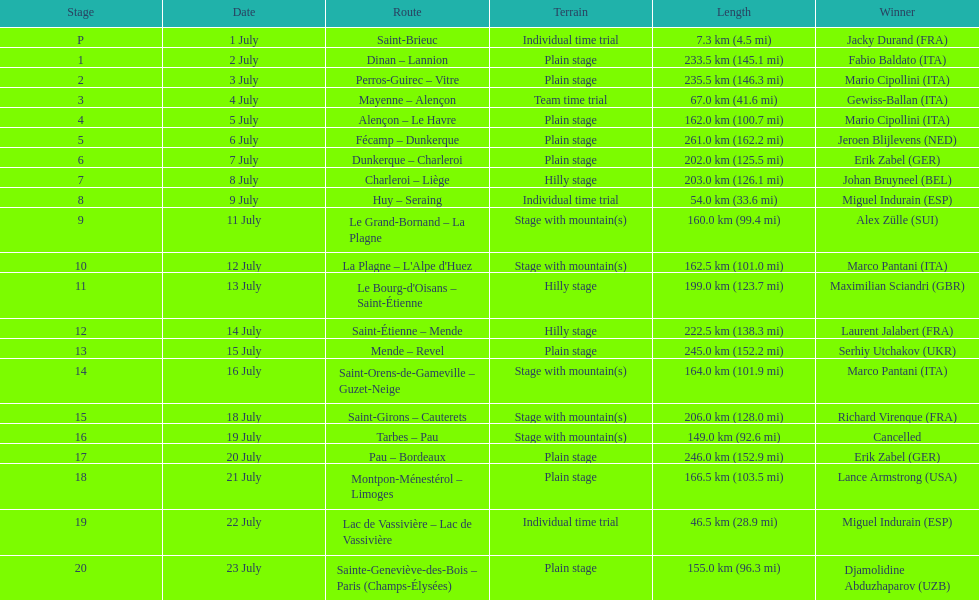What is the length difference between the 20th and 19th stages of the tour de france? 108.5 km. 